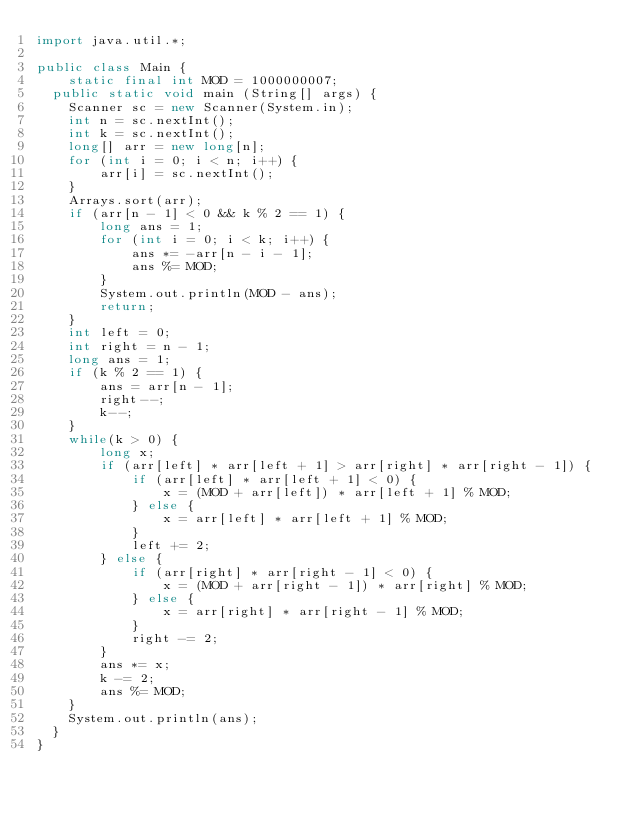Convert code to text. <code><loc_0><loc_0><loc_500><loc_500><_Java_>import java.util.*;

public class Main {
    static final int MOD = 1000000007;
	public static void main (String[] args) {
		Scanner sc = new Scanner(System.in);
		int n = sc.nextInt();
		int k = sc.nextInt();
		long[] arr = new long[n];
		for (int i = 0; i < n; i++) {
		    arr[i] = sc.nextInt();
		}
		Arrays.sort(arr);
		if (arr[n - 1] < 0 && k % 2 == 1) {
		    long ans = 1;
		    for (int i = 0; i < k; i++) {
		        ans *= -arr[n - i - 1];
		        ans %= MOD;
		    }
		    System.out.println(MOD - ans);
		    return;
		}
		int left = 0;
		int right = n - 1;
		long ans = 1;
		if (k % 2 == 1) {
		    ans = arr[n - 1];
		    right--;
		    k--;
		}
		while(k > 0) {
		    long x;
		    if (arr[left] * arr[left + 1] > arr[right] * arr[right - 1]) {
		        if (arr[left] * arr[left + 1] < 0) {
		            x = (MOD + arr[left]) * arr[left + 1] % MOD;
		        } else {
		            x = arr[left] * arr[left + 1] % MOD;
		        }
		        left += 2;
		    } else {
		        if (arr[right] * arr[right - 1] < 0) {
		            x = (MOD + arr[right - 1]) * arr[right] % MOD;
		        } else {
		            x = arr[right] * arr[right - 1] % MOD;
		        }
		        right -= 2;
		    }
		    ans *= x;
		    k -= 2;
		    ans %= MOD;
		}
		System.out.println(ans);
	}
}
</code> 